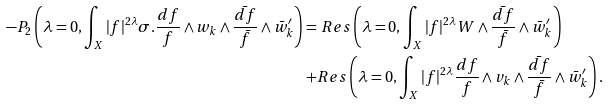Convert formula to latex. <formula><loc_0><loc_0><loc_500><loc_500>- P _ { 2 } \left ( \lambda = 0 , \int _ { X } | f | ^ { 2 \lambda } \sigma . \frac { d f } { f } \wedge w _ { k } \wedge \frac { \bar { d f } } { \bar { f } } \wedge \bar { w } ^ { \prime } _ { k } \right ) = & \ R e s \left ( \lambda = 0 , \int _ { X } | f | ^ { 2 \lambda } W \wedge \frac { \bar { d f } } { \bar { f } } \wedge \bar { w } ^ { \prime } _ { k } \right ) \\ + & R e s \left ( \lambda = 0 , \int _ { X } | f | ^ { 2 \lambda } \frac { d f } { f } \wedge v _ { k } \wedge \frac { \bar { d f } } { \bar { f } } \wedge \bar { w } ^ { \prime } _ { k } \right ) .</formula> 